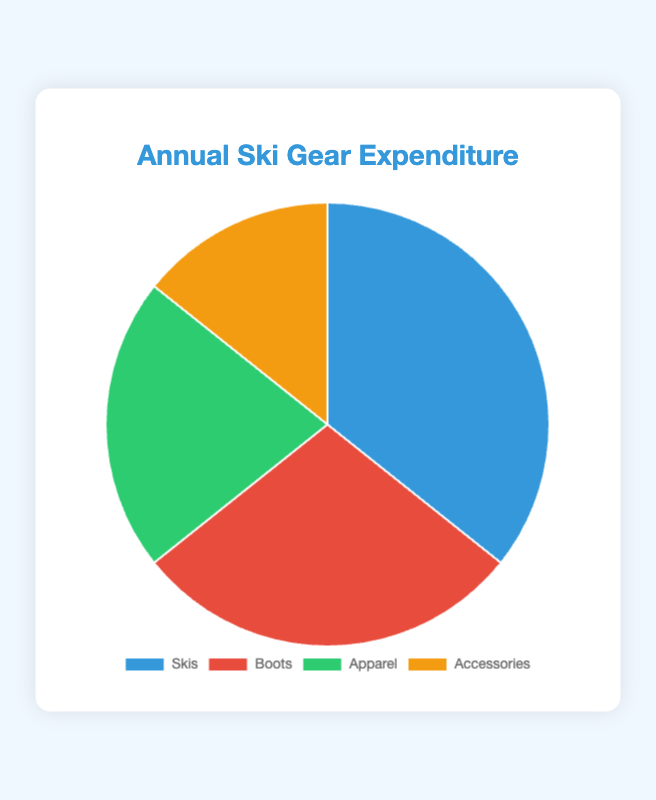What's the total expenditure on ski gear? Add up all the data points: Skis ($500) + Boots ($400) + Apparel ($300) + Accessories ($200) = $1400
Answer: $1400 Which category has the highest expenditure? Skis have the highest expenditure at $500, the largest slice of the pie chart.
Answer: Skis How much more is spent on Skis compared to Accessories? Subtract the expenditure on Accessories from Skis: $500 (Skis) - $200 (Accessories) = $300
Answer: $300 What percentage of the total expenditure is spent on Boots? First, find the total expenditure: $1400. Then, calculate the percentage for Boots: ($400 / $1400) * 100 ≈ 28.57%
Answer: 28.57% Is the expenditure on Apparel more than the expenditure on Accessories and Boots combined? Combine the amounts for Accessories and Boots: $200 + $400 = $600. Compare with Apparel: $300 < $600. So, no.
Answer: No What is the average expenditure per category? Divide the total expenditure by the number of categories: $1400 / 4 = $350
Answer: $350 Which two categories have the lowest expense, and what is their combined total? The lowest expenditures are Apparel ($300) and Accessories ($200). Combined total: $300 + $200 = $500
Answer: Apparel and Accessories; $500 What is the range of expenditures among the categories? Subtract the minimum expenditure from the maximum: $500 (Skis) - $200 (Accessories) = $300
Answer: $300 If you reduce the expenditure on Skis by 10%, how much would it be? Calculate 10% of $500: $500 * 0.10 = $50, then subtract from the original amount: $500 - $50 = $450
Answer: $450 